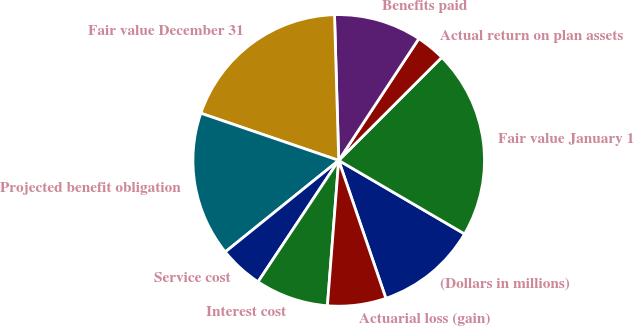<chart> <loc_0><loc_0><loc_500><loc_500><pie_chart><fcel>(Dollars in millions)<fcel>Fair value January 1<fcel>Actual return on plan assets<fcel>Benefits paid<fcel>Fair value December 31<fcel>Projected benefit obligation<fcel>Service cost<fcel>Interest cost<fcel>Actuarial loss (gain)<nl><fcel>11.34%<fcel>20.91%<fcel>3.24%<fcel>9.72%<fcel>19.29%<fcel>16.05%<fcel>4.86%<fcel>8.1%<fcel>6.48%<nl></chart> 